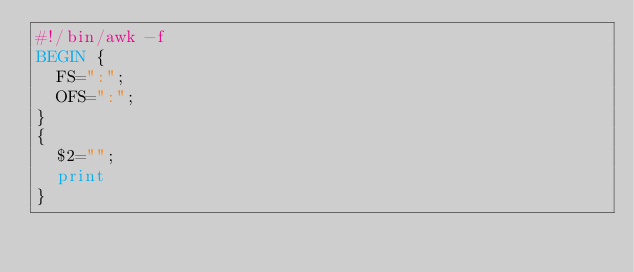Convert code to text. <code><loc_0><loc_0><loc_500><loc_500><_Awk_>#!/bin/awk -f
BEGIN {
	FS=":";
	OFS=":";
}
{
	$2="";
	print
}
</code> 